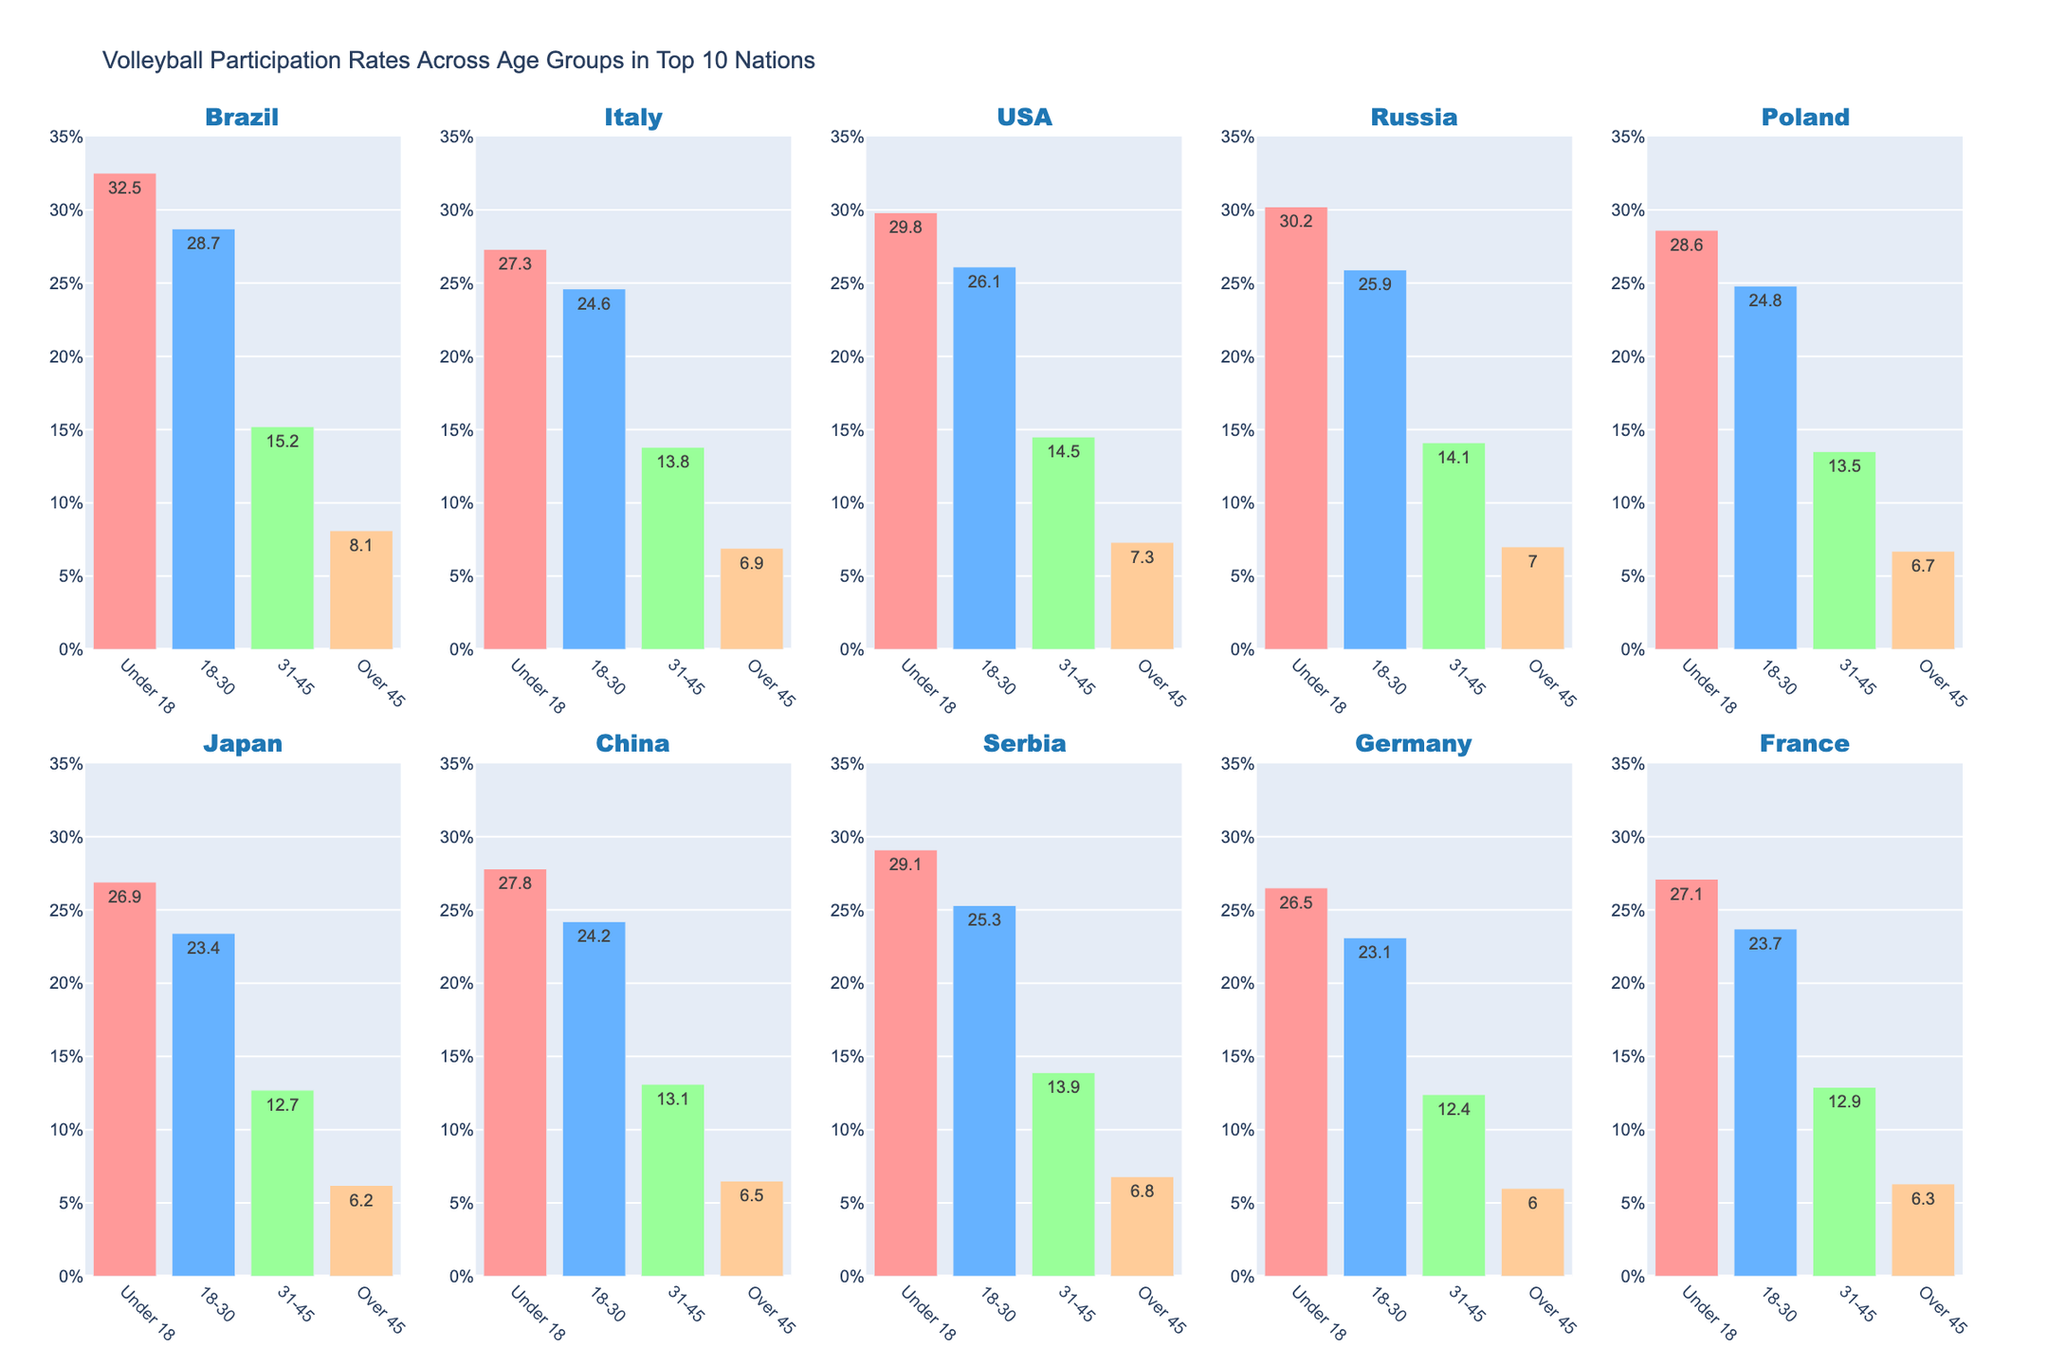Which country has the highest participation rate in the 'Under 18' age group? By observing the bar heights across all countries in the 'Under 18' age groups, Brazil has the highest bar, thus the highest participation rate.
Answer: Brazil Which country has the lowest participation rate in the 'Over 45' age group? By comparing the bar heights across all countries in the 'Over 45' age group, Germany has the shortest bar, indicating the lowest participation rate.
Answer: Germany What is the common trend for participation rates as age increases across all countries? Upon observing all subplots, it is noticeable that the participation rate generally decreases as age increases in every country.
Answer: Decreases How much greater is Brazil's participation rate for 'Under 18' compared to Italy's 'Under 18'? Brazil's participation rate for 'Under 18' is 32.5%, and Italy's is 27.3%. Subtract 27.3 from 32.5.
Answer: 5.2% Which age group shows the smallest variation in participation rates across all nations? By observing the bar heights, the 'Over 45' age group bars are the most uniform, indicating the smallest variation in participation rates.
Answer: Over 45 Rank the participation rates for '18-30' from highest to lowest for USA, Russia, and Poland. The participation rates for '18-30' are USA: 26.1%, Russia: 25.9%, Poland: 24.8%.
Answer: USA > Russia > Poland What is the overall participation trend visible across all countries and age groups? The visual pattern across all countries shows that younger age groups generally have higher participation rates, which decreases progressively in older age groups.
Answer: Decreasing trend with age Between China and Japan, which country has a higher participation rate in the '31-45' age group? When comparing the bar heights for '31-45' between China and Japan, China's bar is higher.
Answer: China How does Italy's '31-45' participation rate compare to Germany's '18-30' rate? Italy’s '31-45' participation rate is 13.8%, and Germany’s '18-30' rate is 23.1%. Italy's rate is lower.
Answer: Lower Which country has the largest drop in participation rate from '18-30' to '31-45'? By calculating the differences for each country, Brazil has the largest drop (28.7 - 15.2 = 13.5).
Answer: Brazil 